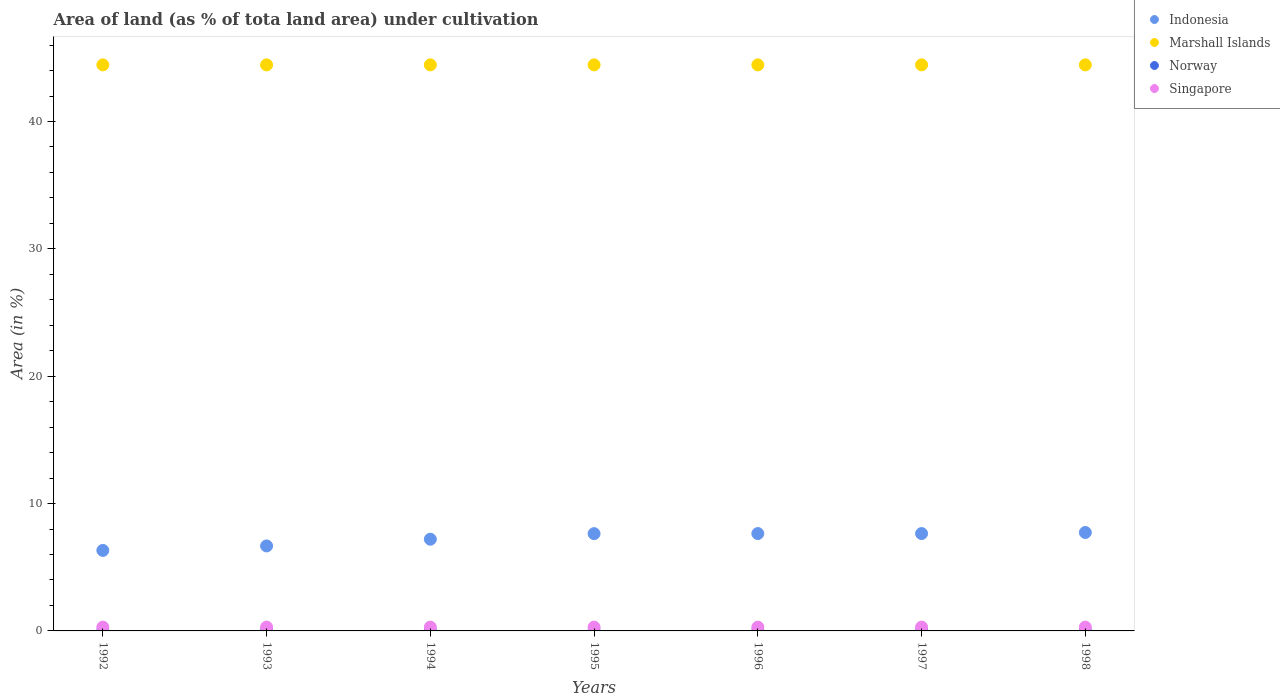How many different coloured dotlines are there?
Make the answer very short. 4. Is the number of dotlines equal to the number of legend labels?
Keep it short and to the point. Yes. What is the percentage of land under cultivation in Norway in 1992?
Ensure brevity in your answer.  0.01. Across all years, what is the maximum percentage of land under cultivation in Singapore?
Provide a short and direct response. 0.3. Across all years, what is the minimum percentage of land under cultivation in Norway?
Give a very brief answer. 0.01. In which year was the percentage of land under cultivation in Singapore maximum?
Provide a short and direct response. 1992. What is the total percentage of land under cultivation in Norway in the graph?
Offer a terse response. 0.1. What is the difference between the percentage of land under cultivation in Marshall Islands in 1994 and that in 1996?
Provide a succinct answer. 0. What is the difference between the percentage of land under cultivation in Norway in 1994 and the percentage of land under cultivation in Singapore in 1995?
Offer a very short reply. -0.28. What is the average percentage of land under cultivation in Indonesia per year?
Offer a terse response. 7.26. In the year 1994, what is the difference between the percentage of land under cultivation in Marshall Islands and percentage of land under cultivation in Indonesia?
Offer a very short reply. 37.24. In how many years, is the percentage of land under cultivation in Marshall Islands greater than 42 %?
Offer a terse response. 7. Is the difference between the percentage of land under cultivation in Marshall Islands in 1992 and 1997 greater than the difference between the percentage of land under cultivation in Indonesia in 1992 and 1997?
Your response must be concise. Yes. Is the sum of the percentage of land under cultivation in Singapore in 1992 and 1997 greater than the maximum percentage of land under cultivation in Marshall Islands across all years?
Make the answer very short. No. Is it the case that in every year, the sum of the percentage of land under cultivation in Marshall Islands and percentage of land under cultivation in Norway  is greater than the percentage of land under cultivation in Singapore?
Offer a terse response. Yes. Does the percentage of land under cultivation in Indonesia monotonically increase over the years?
Provide a short and direct response. No. Is the percentage of land under cultivation in Indonesia strictly greater than the percentage of land under cultivation in Marshall Islands over the years?
Make the answer very short. No. How many dotlines are there?
Your answer should be very brief. 4. How many years are there in the graph?
Give a very brief answer. 7. What is the difference between two consecutive major ticks on the Y-axis?
Provide a succinct answer. 10. Are the values on the major ticks of Y-axis written in scientific E-notation?
Provide a short and direct response. No. Does the graph contain grids?
Offer a terse response. No. Where does the legend appear in the graph?
Ensure brevity in your answer.  Top right. How are the legend labels stacked?
Ensure brevity in your answer.  Vertical. What is the title of the graph?
Your response must be concise. Area of land (as % of tota land area) under cultivation. Does "Cyprus" appear as one of the legend labels in the graph?
Provide a succinct answer. No. What is the label or title of the Y-axis?
Your answer should be compact. Area (in %). What is the Area (in %) in Indonesia in 1992?
Provide a short and direct response. 6.32. What is the Area (in %) in Marshall Islands in 1992?
Give a very brief answer. 44.44. What is the Area (in %) of Norway in 1992?
Keep it short and to the point. 0.01. What is the Area (in %) of Singapore in 1992?
Your answer should be compact. 0.3. What is the Area (in %) in Indonesia in 1993?
Your answer should be compact. 6.67. What is the Area (in %) of Marshall Islands in 1993?
Provide a succinct answer. 44.44. What is the Area (in %) of Norway in 1993?
Your response must be concise. 0.01. What is the Area (in %) in Singapore in 1993?
Your response must be concise. 0.3. What is the Area (in %) of Indonesia in 1994?
Give a very brief answer. 7.2. What is the Area (in %) of Marshall Islands in 1994?
Provide a succinct answer. 44.44. What is the Area (in %) in Norway in 1994?
Your answer should be very brief. 0.01. What is the Area (in %) of Singapore in 1994?
Make the answer very short. 0.3. What is the Area (in %) in Indonesia in 1995?
Provide a succinct answer. 7.64. What is the Area (in %) in Marshall Islands in 1995?
Ensure brevity in your answer.  44.44. What is the Area (in %) of Norway in 1995?
Your answer should be very brief. 0.01. What is the Area (in %) in Singapore in 1995?
Your answer should be very brief. 0.3. What is the Area (in %) of Indonesia in 1996?
Provide a short and direct response. 7.65. What is the Area (in %) in Marshall Islands in 1996?
Ensure brevity in your answer.  44.44. What is the Area (in %) in Norway in 1996?
Ensure brevity in your answer.  0.01. What is the Area (in %) of Singapore in 1996?
Your answer should be compact. 0.3. What is the Area (in %) in Indonesia in 1997?
Keep it short and to the point. 7.65. What is the Area (in %) of Marshall Islands in 1997?
Your response must be concise. 44.44. What is the Area (in %) of Norway in 1997?
Your answer should be very brief. 0.01. What is the Area (in %) of Singapore in 1997?
Provide a succinct answer. 0.3. What is the Area (in %) of Indonesia in 1998?
Your answer should be compact. 7.73. What is the Area (in %) in Marshall Islands in 1998?
Offer a terse response. 44.44. What is the Area (in %) of Norway in 1998?
Give a very brief answer. 0.01. What is the Area (in %) of Singapore in 1998?
Your response must be concise. 0.3. Across all years, what is the maximum Area (in %) in Indonesia?
Offer a very short reply. 7.73. Across all years, what is the maximum Area (in %) of Marshall Islands?
Provide a succinct answer. 44.44. Across all years, what is the maximum Area (in %) of Norway?
Ensure brevity in your answer.  0.01. Across all years, what is the maximum Area (in %) in Singapore?
Your response must be concise. 0.3. Across all years, what is the minimum Area (in %) of Indonesia?
Your answer should be compact. 6.32. Across all years, what is the minimum Area (in %) in Marshall Islands?
Your response must be concise. 44.44. Across all years, what is the minimum Area (in %) in Norway?
Offer a very short reply. 0.01. Across all years, what is the minimum Area (in %) of Singapore?
Give a very brief answer. 0.3. What is the total Area (in %) of Indonesia in the graph?
Keep it short and to the point. 50.85. What is the total Area (in %) in Marshall Islands in the graph?
Provide a succinct answer. 311.11. What is the total Area (in %) in Norway in the graph?
Offer a very short reply. 0.1. What is the total Area (in %) of Singapore in the graph?
Ensure brevity in your answer.  2.09. What is the difference between the Area (in %) in Indonesia in 1992 and that in 1993?
Provide a succinct answer. -0.35. What is the difference between the Area (in %) of Norway in 1992 and that in 1993?
Give a very brief answer. 0. What is the difference between the Area (in %) in Indonesia in 1992 and that in 1994?
Provide a succinct answer. -0.88. What is the difference between the Area (in %) of Norway in 1992 and that in 1994?
Provide a succinct answer. 0. What is the difference between the Area (in %) in Indonesia in 1992 and that in 1995?
Provide a short and direct response. -1.32. What is the difference between the Area (in %) of Marshall Islands in 1992 and that in 1995?
Give a very brief answer. 0. What is the difference between the Area (in %) of Singapore in 1992 and that in 1995?
Ensure brevity in your answer.  0. What is the difference between the Area (in %) in Indonesia in 1992 and that in 1996?
Keep it short and to the point. -1.32. What is the difference between the Area (in %) in Marshall Islands in 1992 and that in 1996?
Provide a short and direct response. 0. What is the difference between the Area (in %) in Norway in 1992 and that in 1996?
Give a very brief answer. 0. What is the difference between the Area (in %) in Singapore in 1992 and that in 1996?
Offer a terse response. 0. What is the difference between the Area (in %) in Indonesia in 1992 and that in 1997?
Your response must be concise. -1.32. What is the difference between the Area (in %) in Singapore in 1992 and that in 1997?
Provide a short and direct response. 0. What is the difference between the Area (in %) of Indonesia in 1992 and that in 1998?
Your answer should be compact. -1.41. What is the difference between the Area (in %) of Marshall Islands in 1992 and that in 1998?
Your answer should be compact. 0. What is the difference between the Area (in %) in Norway in 1992 and that in 1998?
Make the answer very short. 0. What is the difference between the Area (in %) of Singapore in 1992 and that in 1998?
Your response must be concise. 0. What is the difference between the Area (in %) in Indonesia in 1993 and that in 1994?
Offer a terse response. -0.53. What is the difference between the Area (in %) in Norway in 1993 and that in 1994?
Your response must be concise. 0. What is the difference between the Area (in %) in Indonesia in 1993 and that in 1995?
Ensure brevity in your answer.  -0.97. What is the difference between the Area (in %) in Norway in 1993 and that in 1995?
Make the answer very short. 0. What is the difference between the Area (in %) of Singapore in 1993 and that in 1995?
Give a very brief answer. 0. What is the difference between the Area (in %) in Indonesia in 1993 and that in 1996?
Offer a terse response. -0.97. What is the difference between the Area (in %) in Indonesia in 1993 and that in 1997?
Make the answer very short. -0.97. What is the difference between the Area (in %) in Marshall Islands in 1993 and that in 1997?
Provide a short and direct response. 0. What is the difference between the Area (in %) of Norway in 1993 and that in 1997?
Offer a very short reply. 0. What is the difference between the Area (in %) of Singapore in 1993 and that in 1997?
Provide a short and direct response. 0. What is the difference between the Area (in %) of Indonesia in 1993 and that in 1998?
Your answer should be very brief. -1.06. What is the difference between the Area (in %) of Marshall Islands in 1993 and that in 1998?
Your answer should be very brief. 0. What is the difference between the Area (in %) in Singapore in 1993 and that in 1998?
Give a very brief answer. 0. What is the difference between the Area (in %) in Indonesia in 1994 and that in 1995?
Give a very brief answer. -0.44. What is the difference between the Area (in %) of Marshall Islands in 1994 and that in 1995?
Ensure brevity in your answer.  0. What is the difference between the Area (in %) in Singapore in 1994 and that in 1995?
Your answer should be compact. 0. What is the difference between the Area (in %) in Indonesia in 1994 and that in 1996?
Offer a very short reply. -0.44. What is the difference between the Area (in %) in Marshall Islands in 1994 and that in 1996?
Ensure brevity in your answer.  0. What is the difference between the Area (in %) of Singapore in 1994 and that in 1996?
Your response must be concise. 0. What is the difference between the Area (in %) in Indonesia in 1994 and that in 1997?
Your answer should be compact. -0.44. What is the difference between the Area (in %) in Marshall Islands in 1994 and that in 1997?
Your response must be concise. 0. What is the difference between the Area (in %) in Norway in 1994 and that in 1997?
Offer a terse response. 0. What is the difference between the Area (in %) in Indonesia in 1994 and that in 1998?
Your answer should be compact. -0.53. What is the difference between the Area (in %) in Indonesia in 1995 and that in 1996?
Ensure brevity in your answer.  -0.01. What is the difference between the Area (in %) of Marshall Islands in 1995 and that in 1996?
Provide a short and direct response. 0. What is the difference between the Area (in %) of Norway in 1995 and that in 1996?
Your answer should be very brief. 0. What is the difference between the Area (in %) of Indonesia in 1995 and that in 1997?
Offer a very short reply. -0.01. What is the difference between the Area (in %) of Marshall Islands in 1995 and that in 1997?
Give a very brief answer. 0. What is the difference between the Area (in %) in Singapore in 1995 and that in 1997?
Keep it short and to the point. 0. What is the difference between the Area (in %) of Indonesia in 1995 and that in 1998?
Your response must be concise. -0.09. What is the difference between the Area (in %) in Norway in 1995 and that in 1998?
Your answer should be very brief. 0. What is the difference between the Area (in %) in Marshall Islands in 1996 and that in 1997?
Keep it short and to the point. 0. What is the difference between the Area (in %) in Indonesia in 1996 and that in 1998?
Give a very brief answer. -0.08. What is the difference between the Area (in %) in Marshall Islands in 1996 and that in 1998?
Provide a succinct answer. 0. What is the difference between the Area (in %) in Norway in 1996 and that in 1998?
Your answer should be very brief. 0. What is the difference between the Area (in %) in Indonesia in 1997 and that in 1998?
Make the answer very short. -0.08. What is the difference between the Area (in %) in Norway in 1997 and that in 1998?
Your response must be concise. 0. What is the difference between the Area (in %) of Singapore in 1997 and that in 1998?
Your answer should be very brief. 0. What is the difference between the Area (in %) of Indonesia in 1992 and the Area (in %) of Marshall Islands in 1993?
Give a very brief answer. -38.12. What is the difference between the Area (in %) of Indonesia in 1992 and the Area (in %) of Norway in 1993?
Provide a short and direct response. 6.31. What is the difference between the Area (in %) of Indonesia in 1992 and the Area (in %) of Singapore in 1993?
Offer a very short reply. 6.02. What is the difference between the Area (in %) of Marshall Islands in 1992 and the Area (in %) of Norway in 1993?
Make the answer very short. 44.43. What is the difference between the Area (in %) of Marshall Islands in 1992 and the Area (in %) of Singapore in 1993?
Offer a very short reply. 44.15. What is the difference between the Area (in %) of Norway in 1992 and the Area (in %) of Singapore in 1993?
Provide a succinct answer. -0.28. What is the difference between the Area (in %) of Indonesia in 1992 and the Area (in %) of Marshall Islands in 1994?
Offer a very short reply. -38.12. What is the difference between the Area (in %) of Indonesia in 1992 and the Area (in %) of Norway in 1994?
Your response must be concise. 6.31. What is the difference between the Area (in %) in Indonesia in 1992 and the Area (in %) in Singapore in 1994?
Ensure brevity in your answer.  6.02. What is the difference between the Area (in %) in Marshall Islands in 1992 and the Area (in %) in Norway in 1994?
Your response must be concise. 44.43. What is the difference between the Area (in %) of Marshall Islands in 1992 and the Area (in %) of Singapore in 1994?
Keep it short and to the point. 44.15. What is the difference between the Area (in %) of Norway in 1992 and the Area (in %) of Singapore in 1994?
Your answer should be very brief. -0.28. What is the difference between the Area (in %) in Indonesia in 1992 and the Area (in %) in Marshall Islands in 1995?
Keep it short and to the point. -38.12. What is the difference between the Area (in %) in Indonesia in 1992 and the Area (in %) in Norway in 1995?
Offer a terse response. 6.31. What is the difference between the Area (in %) in Indonesia in 1992 and the Area (in %) in Singapore in 1995?
Offer a very short reply. 6.02. What is the difference between the Area (in %) in Marshall Islands in 1992 and the Area (in %) in Norway in 1995?
Offer a very short reply. 44.43. What is the difference between the Area (in %) of Marshall Islands in 1992 and the Area (in %) of Singapore in 1995?
Provide a succinct answer. 44.15. What is the difference between the Area (in %) of Norway in 1992 and the Area (in %) of Singapore in 1995?
Offer a terse response. -0.28. What is the difference between the Area (in %) of Indonesia in 1992 and the Area (in %) of Marshall Islands in 1996?
Your answer should be compact. -38.12. What is the difference between the Area (in %) in Indonesia in 1992 and the Area (in %) in Norway in 1996?
Keep it short and to the point. 6.31. What is the difference between the Area (in %) in Indonesia in 1992 and the Area (in %) in Singapore in 1996?
Give a very brief answer. 6.02. What is the difference between the Area (in %) in Marshall Islands in 1992 and the Area (in %) in Norway in 1996?
Ensure brevity in your answer.  44.43. What is the difference between the Area (in %) of Marshall Islands in 1992 and the Area (in %) of Singapore in 1996?
Keep it short and to the point. 44.15. What is the difference between the Area (in %) of Norway in 1992 and the Area (in %) of Singapore in 1996?
Your answer should be very brief. -0.28. What is the difference between the Area (in %) of Indonesia in 1992 and the Area (in %) of Marshall Islands in 1997?
Keep it short and to the point. -38.12. What is the difference between the Area (in %) in Indonesia in 1992 and the Area (in %) in Norway in 1997?
Keep it short and to the point. 6.31. What is the difference between the Area (in %) of Indonesia in 1992 and the Area (in %) of Singapore in 1997?
Make the answer very short. 6.02. What is the difference between the Area (in %) in Marshall Islands in 1992 and the Area (in %) in Norway in 1997?
Your answer should be compact. 44.43. What is the difference between the Area (in %) of Marshall Islands in 1992 and the Area (in %) of Singapore in 1997?
Provide a short and direct response. 44.15. What is the difference between the Area (in %) in Norway in 1992 and the Area (in %) in Singapore in 1997?
Ensure brevity in your answer.  -0.28. What is the difference between the Area (in %) in Indonesia in 1992 and the Area (in %) in Marshall Islands in 1998?
Your answer should be very brief. -38.12. What is the difference between the Area (in %) in Indonesia in 1992 and the Area (in %) in Norway in 1998?
Ensure brevity in your answer.  6.31. What is the difference between the Area (in %) in Indonesia in 1992 and the Area (in %) in Singapore in 1998?
Offer a very short reply. 6.02. What is the difference between the Area (in %) of Marshall Islands in 1992 and the Area (in %) of Norway in 1998?
Your answer should be very brief. 44.43. What is the difference between the Area (in %) of Marshall Islands in 1992 and the Area (in %) of Singapore in 1998?
Ensure brevity in your answer.  44.15. What is the difference between the Area (in %) of Norway in 1992 and the Area (in %) of Singapore in 1998?
Make the answer very short. -0.28. What is the difference between the Area (in %) of Indonesia in 1993 and the Area (in %) of Marshall Islands in 1994?
Your response must be concise. -37.77. What is the difference between the Area (in %) of Indonesia in 1993 and the Area (in %) of Norway in 1994?
Your answer should be compact. 6.66. What is the difference between the Area (in %) in Indonesia in 1993 and the Area (in %) in Singapore in 1994?
Offer a very short reply. 6.37. What is the difference between the Area (in %) in Marshall Islands in 1993 and the Area (in %) in Norway in 1994?
Your response must be concise. 44.43. What is the difference between the Area (in %) of Marshall Islands in 1993 and the Area (in %) of Singapore in 1994?
Your response must be concise. 44.15. What is the difference between the Area (in %) in Norway in 1993 and the Area (in %) in Singapore in 1994?
Your answer should be compact. -0.28. What is the difference between the Area (in %) in Indonesia in 1993 and the Area (in %) in Marshall Islands in 1995?
Ensure brevity in your answer.  -37.77. What is the difference between the Area (in %) in Indonesia in 1993 and the Area (in %) in Norway in 1995?
Offer a very short reply. 6.66. What is the difference between the Area (in %) in Indonesia in 1993 and the Area (in %) in Singapore in 1995?
Offer a terse response. 6.37. What is the difference between the Area (in %) in Marshall Islands in 1993 and the Area (in %) in Norway in 1995?
Provide a succinct answer. 44.43. What is the difference between the Area (in %) in Marshall Islands in 1993 and the Area (in %) in Singapore in 1995?
Provide a short and direct response. 44.15. What is the difference between the Area (in %) in Norway in 1993 and the Area (in %) in Singapore in 1995?
Offer a very short reply. -0.28. What is the difference between the Area (in %) of Indonesia in 1993 and the Area (in %) of Marshall Islands in 1996?
Give a very brief answer. -37.77. What is the difference between the Area (in %) of Indonesia in 1993 and the Area (in %) of Norway in 1996?
Provide a succinct answer. 6.66. What is the difference between the Area (in %) in Indonesia in 1993 and the Area (in %) in Singapore in 1996?
Provide a short and direct response. 6.37. What is the difference between the Area (in %) in Marshall Islands in 1993 and the Area (in %) in Norway in 1996?
Make the answer very short. 44.43. What is the difference between the Area (in %) of Marshall Islands in 1993 and the Area (in %) of Singapore in 1996?
Offer a very short reply. 44.15. What is the difference between the Area (in %) in Norway in 1993 and the Area (in %) in Singapore in 1996?
Offer a terse response. -0.28. What is the difference between the Area (in %) in Indonesia in 1993 and the Area (in %) in Marshall Islands in 1997?
Offer a very short reply. -37.77. What is the difference between the Area (in %) in Indonesia in 1993 and the Area (in %) in Norway in 1997?
Your answer should be compact. 6.66. What is the difference between the Area (in %) in Indonesia in 1993 and the Area (in %) in Singapore in 1997?
Your answer should be very brief. 6.37. What is the difference between the Area (in %) in Marshall Islands in 1993 and the Area (in %) in Norway in 1997?
Your answer should be compact. 44.43. What is the difference between the Area (in %) in Marshall Islands in 1993 and the Area (in %) in Singapore in 1997?
Ensure brevity in your answer.  44.15. What is the difference between the Area (in %) in Norway in 1993 and the Area (in %) in Singapore in 1997?
Your response must be concise. -0.28. What is the difference between the Area (in %) in Indonesia in 1993 and the Area (in %) in Marshall Islands in 1998?
Your answer should be compact. -37.77. What is the difference between the Area (in %) in Indonesia in 1993 and the Area (in %) in Norway in 1998?
Offer a terse response. 6.66. What is the difference between the Area (in %) of Indonesia in 1993 and the Area (in %) of Singapore in 1998?
Your answer should be compact. 6.37. What is the difference between the Area (in %) of Marshall Islands in 1993 and the Area (in %) of Norway in 1998?
Your response must be concise. 44.43. What is the difference between the Area (in %) in Marshall Islands in 1993 and the Area (in %) in Singapore in 1998?
Your answer should be compact. 44.15. What is the difference between the Area (in %) in Norway in 1993 and the Area (in %) in Singapore in 1998?
Offer a terse response. -0.28. What is the difference between the Area (in %) in Indonesia in 1994 and the Area (in %) in Marshall Islands in 1995?
Make the answer very short. -37.24. What is the difference between the Area (in %) in Indonesia in 1994 and the Area (in %) in Norway in 1995?
Provide a short and direct response. 7.19. What is the difference between the Area (in %) in Indonesia in 1994 and the Area (in %) in Singapore in 1995?
Offer a very short reply. 6.9. What is the difference between the Area (in %) of Marshall Islands in 1994 and the Area (in %) of Norway in 1995?
Ensure brevity in your answer.  44.43. What is the difference between the Area (in %) of Marshall Islands in 1994 and the Area (in %) of Singapore in 1995?
Keep it short and to the point. 44.15. What is the difference between the Area (in %) in Norway in 1994 and the Area (in %) in Singapore in 1995?
Offer a very short reply. -0.28. What is the difference between the Area (in %) in Indonesia in 1994 and the Area (in %) in Marshall Islands in 1996?
Make the answer very short. -37.24. What is the difference between the Area (in %) of Indonesia in 1994 and the Area (in %) of Norway in 1996?
Ensure brevity in your answer.  7.19. What is the difference between the Area (in %) in Indonesia in 1994 and the Area (in %) in Singapore in 1996?
Offer a very short reply. 6.9. What is the difference between the Area (in %) in Marshall Islands in 1994 and the Area (in %) in Norway in 1996?
Offer a very short reply. 44.43. What is the difference between the Area (in %) of Marshall Islands in 1994 and the Area (in %) of Singapore in 1996?
Your response must be concise. 44.15. What is the difference between the Area (in %) of Norway in 1994 and the Area (in %) of Singapore in 1996?
Your answer should be very brief. -0.28. What is the difference between the Area (in %) in Indonesia in 1994 and the Area (in %) in Marshall Islands in 1997?
Provide a short and direct response. -37.24. What is the difference between the Area (in %) of Indonesia in 1994 and the Area (in %) of Norway in 1997?
Ensure brevity in your answer.  7.19. What is the difference between the Area (in %) of Indonesia in 1994 and the Area (in %) of Singapore in 1997?
Your answer should be very brief. 6.9. What is the difference between the Area (in %) of Marshall Islands in 1994 and the Area (in %) of Norway in 1997?
Keep it short and to the point. 44.43. What is the difference between the Area (in %) of Marshall Islands in 1994 and the Area (in %) of Singapore in 1997?
Your response must be concise. 44.15. What is the difference between the Area (in %) of Norway in 1994 and the Area (in %) of Singapore in 1997?
Your answer should be compact. -0.28. What is the difference between the Area (in %) in Indonesia in 1994 and the Area (in %) in Marshall Islands in 1998?
Make the answer very short. -37.24. What is the difference between the Area (in %) of Indonesia in 1994 and the Area (in %) of Norway in 1998?
Your answer should be very brief. 7.19. What is the difference between the Area (in %) of Indonesia in 1994 and the Area (in %) of Singapore in 1998?
Keep it short and to the point. 6.9. What is the difference between the Area (in %) of Marshall Islands in 1994 and the Area (in %) of Norway in 1998?
Make the answer very short. 44.43. What is the difference between the Area (in %) in Marshall Islands in 1994 and the Area (in %) in Singapore in 1998?
Your answer should be very brief. 44.15. What is the difference between the Area (in %) of Norway in 1994 and the Area (in %) of Singapore in 1998?
Offer a very short reply. -0.28. What is the difference between the Area (in %) of Indonesia in 1995 and the Area (in %) of Marshall Islands in 1996?
Offer a very short reply. -36.81. What is the difference between the Area (in %) of Indonesia in 1995 and the Area (in %) of Norway in 1996?
Provide a succinct answer. 7.62. What is the difference between the Area (in %) in Indonesia in 1995 and the Area (in %) in Singapore in 1996?
Your answer should be very brief. 7.34. What is the difference between the Area (in %) in Marshall Islands in 1995 and the Area (in %) in Norway in 1996?
Keep it short and to the point. 44.43. What is the difference between the Area (in %) in Marshall Islands in 1995 and the Area (in %) in Singapore in 1996?
Your answer should be very brief. 44.15. What is the difference between the Area (in %) of Norway in 1995 and the Area (in %) of Singapore in 1996?
Give a very brief answer. -0.28. What is the difference between the Area (in %) of Indonesia in 1995 and the Area (in %) of Marshall Islands in 1997?
Give a very brief answer. -36.81. What is the difference between the Area (in %) of Indonesia in 1995 and the Area (in %) of Norway in 1997?
Ensure brevity in your answer.  7.62. What is the difference between the Area (in %) of Indonesia in 1995 and the Area (in %) of Singapore in 1997?
Keep it short and to the point. 7.34. What is the difference between the Area (in %) in Marshall Islands in 1995 and the Area (in %) in Norway in 1997?
Keep it short and to the point. 44.43. What is the difference between the Area (in %) in Marshall Islands in 1995 and the Area (in %) in Singapore in 1997?
Offer a very short reply. 44.15. What is the difference between the Area (in %) in Norway in 1995 and the Area (in %) in Singapore in 1997?
Your response must be concise. -0.28. What is the difference between the Area (in %) of Indonesia in 1995 and the Area (in %) of Marshall Islands in 1998?
Offer a terse response. -36.81. What is the difference between the Area (in %) in Indonesia in 1995 and the Area (in %) in Norway in 1998?
Your response must be concise. 7.62. What is the difference between the Area (in %) of Indonesia in 1995 and the Area (in %) of Singapore in 1998?
Offer a very short reply. 7.34. What is the difference between the Area (in %) in Marshall Islands in 1995 and the Area (in %) in Norway in 1998?
Offer a terse response. 44.43. What is the difference between the Area (in %) of Marshall Islands in 1995 and the Area (in %) of Singapore in 1998?
Keep it short and to the point. 44.15. What is the difference between the Area (in %) of Norway in 1995 and the Area (in %) of Singapore in 1998?
Give a very brief answer. -0.28. What is the difference between the Area (in %) in Indonesia in 1996 and the Area (in %) in Marshall Islands in 1997?
Keep it short and to the point. -36.8. What is the difference between the Area (in %) of Indonesia in 1996 and the Area (in %) of Norway in 1997?
Provide a succinct answer. 7.63. What is the difference between the Area (in %) in Indonesia in 1996 and the Area (in %) in Singapore in 1997?
Offer a very short reply. 7.35. What is the difference between the Area (in %) in Marshall Islands in 1996 and the Area (in %) in Norway in 1997?
Make the answer very short. 44.43. What is the difference between the Area (in %) of Marshall Islands in 1996 and the Area (in %) of Singapore in 1997?
Keep it short and to the point. 44.15. What is the difference between the Area (in %) in Norway in 1996 and the Area (in %) in Singapore in 1997?
Your answer should be very brief. -0.28. What is the difference between the Area (in %) in Indonesia in 1996 and the Area (in %) in Marshall Islands in 1998?
Offer a very short reply. -36.8. What is the difference between the Area (in %) of Indonesia in 1996 and the Area (in %) of Norway in 1998?
Provide a short and direct response. 7.63. What is the difference between the Area (in %) in Indonesia in 1996 and the Area (in %) in Singapore in 1998?
Provide a short and direct response. 7.35. What is the difference between the Area (in %) of Marshall Islands in 1996 and the Area (in %) of Norway in 1998?
Ensure brevity in your answer.  44.43. What is the difference between the Area (in %) of Marshall Islands in 1996 and the Area (in %) of Singapore in 1998?
Make the answer very short. 44.15. What is the difference between the Area (in %) in Norway in 1996 and the Area (in %) in Singapore in 1998?
Provide a short and direct response. -0.28. What is the difference between the Area (in %) of Indonesia in 1997 and the Area (in %) of Marshall Islands in 1998?
Offer a terse response. -36.8. What is the difference between the Area (in %) in Indonesia in 1997 and the Area (in %) in Norway in 1998?
Keep it short and to the point. 7.63. What is the difference between the Area (in %) of Indonesia in 1997 and the Area (in %) of Singapore in 1998?
Your response must be concise. 7.35. What is the difference between the Area (in %) of Marshall Islands in 1997 and the Area (in %) of Norway in 1998?
Make the answer very short. 44.43. What is the difference between the Area (in %) in Marshall Islands in 1997 and the Area (in %) in Singapore in 1998?
Offer a very short reply. 44.15. What is the difference between the Area (in %) in Norway in 1997 and the Area (in %) in Singapore in 1998?
Provide a succinct answer. -0.28. What is the average Area (in %) of Indonesia per year?
Offer a very short reply. 7.26. What is the average Area (in %) in Marshall Islands per year?
Give a very brief answer. 44.44. What is the average Area (in %) in Norway per year?
Your answer should be compact. 0.01. What is the average Area (in %) in Singapore per year?
Your answer should be very brief. 0.3. In the year 1992, what is the difference between the Area (in %) in Indonesia and Area (in %) in Marshall Islands?
Provide a short and direct response. -38.12. In the year 1992, what is the difference between the Area (in %) in Indonesia and Area (in %) in Norway?
Your response must be concise. 6.31. In the year 1992, what is the difference between the Area (in %) of Indonesia and Area (in %) of Singapore?
Give a very brief answer. 6.02. In the year 1992, what is the difference between the Area (in %) of Marshall Islands and Area (in %) of Norway?
Make the answer very short. 44.43. In the year 1992, what is the difference between the Area (in %) in Marshall Islands and Area (in %) in Singapore?
Your answer should be compact. 44.15. In the year 1992, what is the difference between the Area (in %) of Norway and Area (in %) of Singapore?
Your answer should be very brief. -0.28. In the year 1993, what is the difference between the Area (in %) in Indonesia and Area (in %) in Marshall Islands?
Give a very brief answer. -37.77. In the year 1993, what is the difference between the Area (in %) of Indonesia and Area (in %) of Norway?
Provide a succinct answer. 6.66. In the year 1993, what is the difference between the Area (in %) in Indonesia and Area (in %) in Singapore?
Offer a very short reply. 6.37. In the year 1993, what is the difference between the Area (in %) of Marshall Islands and Area (in %) of Norway?
Your response must be concise. 44.43. In the year 1993, what is the difference between the Area (in %) of Marshall Islands and Area (in %) of Singapore?
Your answer should be compact. 44.15. In the year 1993, what is the difference between the Area (in %) in Norway and Area (in %) in Singapore?
Your response must be concise. -0.28. In the year 1994, what is the difference between the Area (in %) of Indonesia and Area (in %) of Marshall Islands?
Keep it short and to the point. -37.24. In the year 1994, what is the difference between the Area (in %) in Indonesia and Area (in %) in Norway?
Offer a very short reply. 7.19. In the year 1994, what is the difference between the Area (in %) in Indonesia and Area (in %) in Singapore?
Offer a terse response. 6.9. In the year 1994, what is the difference between the Area (in %) of Marshall Islands and Area (in %) of Norway?
Provide a succinct answer. 44.43. In the year 1994, what is the difference between the Area (in %) in Marshall Islands and Area (in %) in Singapore?
Give a very brief answer. 44.15. In the year 1994, what is the difference between the Area (in %) in Norway and Area (in %) in Singapore?
Provide a short and direct response. -0.28. In the year 1995, what is the difference between the Area (in %) of Indonesia and Area (in %) of Marshall Islands?
Offer a very short reply. -36.81. In the year 1995, what is the difference between the Area (in %) in Indonesia and Area (in %) in Norway?
Your answer should be very brief. 7.62. In the year 1995, what is the difference between the Area (in %) in Indonesia and Area (in %) in Singapore?
Provide a succinct answer. 7.34. In the year 1995, what is the difference between the Area (in %) in Marshall Islands and Area (in %) in Norway?
Your answer should be very brief. 44.43. In the year 1995, what is the difference between the Area (in %) in Marshall Islands and Area (in %) in Singapore?
Offer a very short reply. 44.15. In the year 1995, what is the difference between the Area (in %) of Norway and Area (in %) of Singapore?
Provide a short and direct response. -0.28. In the year 1996, what is the difference between the Area (in %) in Indonesia and Area (in %) in Marshall Islands?
Give a very brief answer. -36.8. In the year 1996, what is the difference between the Area (in %) of Indonesia and Area (in %) of Norway?
Offer a very short reply. 7.63. In the year 1996, what is the difference between the Area (in %) in Indonesia and Area (in %) in Singapore?
Provide a succinct answer. 7.35. In the year 1996, what is the difference between the Area (in %) in Marshall Islands and Area (in %) in Norway?
Make the answer very short. 44.43. In the year 1996, what is the difference between the Area (in %) in Marshall Islands and Area (in %) in Singapore?
Keep it short and to the point. 44.15. In the year 1996, what is the difference between the Area (in %) in Norway and Area (in %) in Singapore?
Your answer should be compact. -0.28. In the year 1997, what is the difference between the Area (in %) in Indonesia and Area (in %) in Marshall Islands?
Give a very brief answer. -36.8. In the year 1997, what is the difference between the Area (in %) in Indonesia and Area (in %) in Norway?
Make the answer very short. 7.63. In the year 1997, what is the difference between the Area (in %) of Indonesia and Area (in %) of Singapore?
Offer a very short reply. 7.35. In the year 1997, what is the difference between the Area (in %) of Marshall Islands and Area (in %) of Norway?
Make the answer very short. 44.43. In the year 1997, what is the difference between the Area (in %) in Marshall Islands and Area (in %) in Singapore?
Make the answer very short. 44.15. In the year 1997, what is the difference between the Area (in %) in Norway and Area (in %) in Singapore?
Offer a very short reply. -0.28. In the year 1998, what is the difference between the Area (in %) in Indonesia and Area (in %) in Marshall Islands?
Provide a short and direct response. -36.72. In the year 1998, what is the difference between the Area (in %) of Indonesia and Area (in %) of Norway?
Your answer should be very brief. 7.71. In the year 1998, what is the difference between the Area (in %) in Indonesia and Area (in %) in Singapore?
Make the answer very short. 7.43. In the year 1998, what is the difference between the Area (in %) in Marshall Islands and Area (in %) in Norway?
Offer a terse response. 44.43. In the year 1998, what is the difference between the Area (in %) of Marshall Islands and Area (in %) of Singapore?
Provide a succinct answer. 44.15. In the year 1998, what is the difference between the Area (in %) of Norway and Area (in %) of Singapore?
Offer a terse response. -0.28. What is the ratio of the Area (in %) of Indonesia in 1992 to that in 1993?
Make the answer very short. 0.95. What is the ratio of the Area (in %) of Norway in 1992 to that in 1993?
Ensure brevity in your answer.  1. What is the ratio of the Area (in %) of Singapore in 1992 to that in 1993?
Your answer should be compact. 1. What is the ratio of the Area (in %) in Indonesia in 1992 to that in 1994?
Provide a short and direct response. 0.88. What is the ratio of the Area (in %) in Norway in 1992 to that in 1994?
Give a very brief answer. 1. What is the ratio of the Area (in %) of Indonesia in 1992 to that in 1995?
Keep it short and to the point. 0.83. What is the ratio of the Area (in %) in Marshall Islands in 1992 to that in 1995?
Your answer should be compact. 1. What is the ratio of the Area (in %) in Norway in 1992 to that in 1995?
Offer a very short reply. 1. What is the ratio of the Area (in %) of Singapore in 1992 to that in 1995?
Your response must be concise. 1. What is the ratio of the Area (in %) in Indonesia in 1992 to that in 1996?
Offer a very short reply. 0.83. What is the ratio of the Area (in %) of Norway in 1992 to that in 1996?
Make the answer very short. 1. What is the ratio of the Area (in %) in Singapore in 1992 to that in 1996?
Keep it short and to the point. 1. What is the ratio of the Area (in %) of Indonesia in 1992 to that in 1997?
Provide a succinct answer. 0.83. What is the ratio of the Area (in %) in Indonesia in 1992 to that in 1998?
Provide a succinct answer. 0.82. What is the ratio of the Area (in %) of Norway in 1992 to that in 1998?
Keep it short and to the point. 1. What is the ratio of the Area (in %) of Singapore in 1992 to that in 1998?
Offer a very short reply. 1. What is the ratio of the Area (in %) in Indonesia in 1993 to that in 1994?
Your response must be concise. 0.93. What is the ratio of the Area (in %) of Marshall Islands in 1993 to that in 1994?
Provide a short and direct response. 1. What is the ratio of the Area (in %) in Indonesia in 1993 to that in 1995?
Keep it short and to the point. 0.87. What is the ratio of the Area (in %) in Marshall Islands in 1993 to that in 1995?
Ensure brevity in your answer.  1. What is the ratio of the Area (in %) of Indonesia in 1993 to that in 1996?
Ensure brevity in your answer.  0.87. What is the ratio of the Area (in %) in Norway in 1993 to that in 1996?
Give a very brief answer. 1. What is the ratio of the Area (in %) of Singapore in 1993 to that in 1996?
Give a very brief answer. 1. What is the ratio of the Area (in %) of Indonesia in 1993 to that in 1997?
Provide a short and direct response. 0.87. What is the ratio of the Area (in %) in Norway in 1993 to that in 1997?
Your answer should be compact. 1. What is the ratio of the Area (in %) in Indonesia in 1993 to that in 1998?
Offer a very short reply. 0.86. What is the ratio of the Area (in %) in Marshall Islands in 1993 to that in 1998?
Keep it short and to the point. 1. What is the ratio of the Area (in %) in Singapore in 1993 to that in 1998?
Keep it short and to the point. 1. What is the ratio of the Area (in %) of Indonesia in 1994 to that in 1995?
Make the answer very short. 0.94. What is the ratio of the Area (in %) of Marshall Islands in 1994 to that in 1995?
Give a very brief answer. 1. What is the ratio of the Area (in %) of Norway in 1994 to that in 1995?
Provide a short and direct response. 1. What is the ratio of the Area (in %) of Indonesia in 1994 to that in 1996?
Keep it short and to the point. 0.94. What is the ratio of the Area (in %) in Marshall Islands in 1994 to that in 1996?
Ensure brevity in your answer.  1. What is the ratio of the Area (in %) of Singapore in 1994 to that in 1996?
Your answer should be compact. 1. What is the ratio of the Area (in %) of Indonesia in 1994 to that in 1997?
Provide a short and direct response. 0.94. What is the ratio of the Area (in %) in Singapore in 1994 to that in 1997?
Offer a terse response. 1. What is the ratio of the Area (in %) of Indonesia in 1994 to that in 1998?
Offer a terse response. 0.93. What is the ratio of the Area (in %) in Marshall Islands in 1994 to that in 1998?
Make the answer very short. 1. What is the ratio of the Area (in %) of Indonesia in 1995 to that in 1996?
Provide a short and direct response. 1. What is the ratio of the Area (in %) in Singapore in 1995 to that in 1996?
Make the answer very short. 1. What is the ratio of the Area (in %) in Marshall Islands in 1995 to that in 1997?
Provide a succinct answer. 1. What is the ratio of the Area (in %) of Indonesia in 1995 to that in 1998?
Keep it short and to the point. 0.99. What is the ratio of the Area (in %) in Norway in 1995 to that in 1998?
Your response must be concise. 1. What is the ratio of the Area (in %) of Singapore in 1995 to that in 1998?
Offer a very short reply. 1. What is the ratio of the Area (in %) in Marshall Islands in 1996 to that in 1997?
Make the answer very short. 1. What is the ratio of the Area (in %) in Indonesia in 1996 to that in 1998?
Provide a short and direct response. 0.99. What is the ratio of the Area (in %) of Indonesia in 1997 to that in 1998?
Provide a short and direct response. 0.99. What is the ratio of the Area (in %) in Norway in 1997 to that in 1998?
Your answer should be very brief. 1. What is the difference between the highest and the second highest Area (in %) of Indonesia?
Give a very brief answer. 0.08. What is the difference between the highest and the second highest Area (in %) in Singapore?
Provide a short and direct response. 0. What is the difference between the highest and the lowest Area (in %) of Indonesia?
Provide a short and direct response. 1.41. What is the difference between the highest and the lowest Area (in %) of Singapore?
Your response must be concise. 0. 